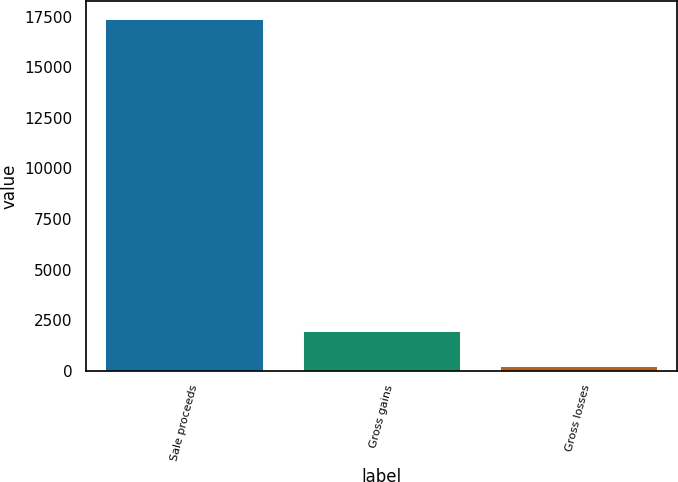Convert chart. <chart><loc_0><loc_0><loc_500><loc_500><bar_chart><fcel>Sale proceeds<fcel>Gross gains<fcel>Gross losses<nl><fcel>17393<fcel>1940<fcel>223<nl></chart> 